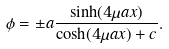Convert formula to latex. <formula><loc_0><loc_0><loc_500><loc_500>\phi = \pm a \frac { \sinh ( 4 \mu a x ) } { \cosh ( 4 \mu a x ) + c } .</formula> 